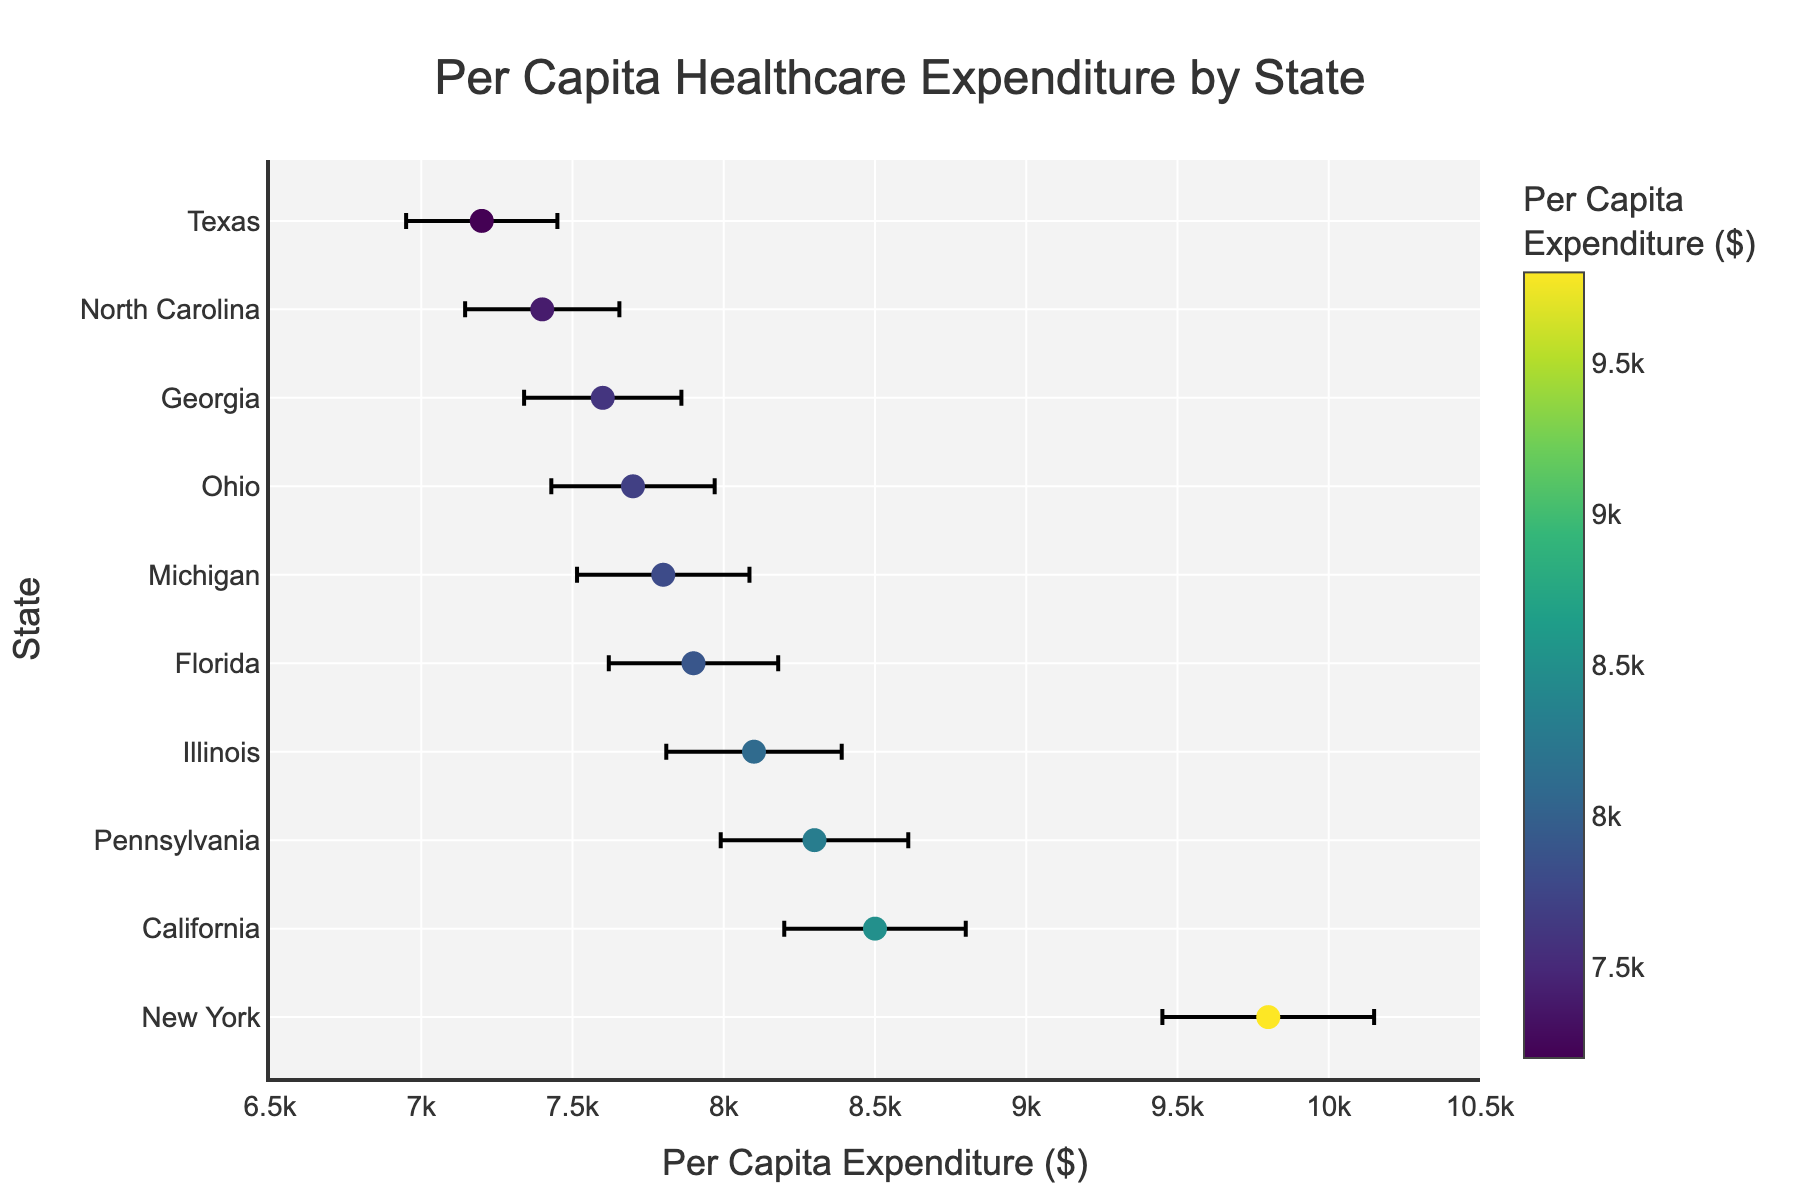What is the title of the figure? The title of the figure is positioned at the top center and slightly above the scatter plot. The text is "Per Capita Healthcare Expenditure by State"
Answer: Per Capita Healthcare Expenditure by State What is the range of the x-axis in the figure? The range of the x-axis is determined by looking at the minimum and maximum values on the horizontal axis. It spans from $6500 to $10500.
Answer: $6500 to $10500 Which state has the highest per capita healthcare expenditure? The state with the highest value will be positioned at the top of the y-axis in the sorted data. In this case, New York has the highest expenditure with a value of $9800.
Answer: New York What is the average per capita expenditure of the states shown in the plot? To find the average, sum all the per capita expenditures (8500 + 7200 + 9800 + 7900 + 8100 + 8300 + 7700 + 7600 + 7400 + 7800) which is 80300, and divide by the number of states (10). The average is 80300/10.
Answer: $8030 Which state has the largest error bar, indicating the most uncertainty in its expenditure estimate? The largest error bar can be seen from the length of the horizontal lines on the plot. New York has the largest standard error of $350.
Answer: New York What is the difference in per capita healthcare expenditure between California and Texas? Subtract the per capita expenditure of Texas from that of California (8500 - 7200).
Answer: $1300 How does the per capita expenditure of Ohio compare to that of Georgia? Ohio's expenditure ($7700) is slightly higher than that of Georgia ($7600).
Answer: Ohio has a higher expenditure Which states have a per capita healthcare expenditure above the average of $8030? States with expenditures above the average can be identified by looking at values greater than $8030. These states are California, New York, Pennsylvania, Illinois, and Florida.
Answer: California, New York, Pennsylvania, Illinois, Florida Is Michigan's per capita healthcare expenditure within one standard error of Ohio's? Michigan's expenditure is $7800, and Ohio's is $7700 with a standard error of $270. Ohio's range with one standard error is ($7700 - $270, $7700 + $270), i.e., [$7430, $7970]. Michigan's value $7800 falls within this range.
Answer: Yes How does the color scale on the markers relate to the per capita expenditure? The color scale from Viridis is used where lighter colors indicate higher per capita expenditures, and darker colors indicate lower expenditures. The colorbar shows this relationship clearly.
Answer: Lighter colors indicate higher expenditures 